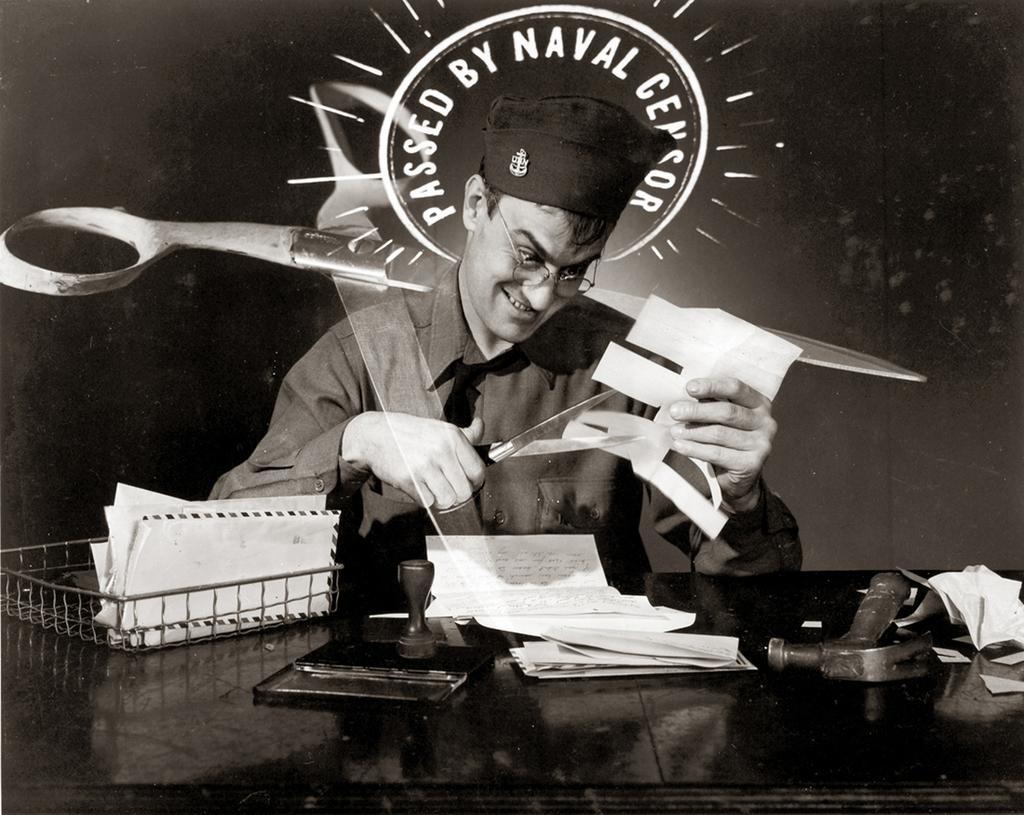Could you give a brief overview of what you see in this image? In the image we can see a person wearing clothes, spectacles and a cap. This person is sitting and holding a scissor in his one hand and on the other hand there is a paper. This is a tray, stamp, papers and an object. This is a watermark. 